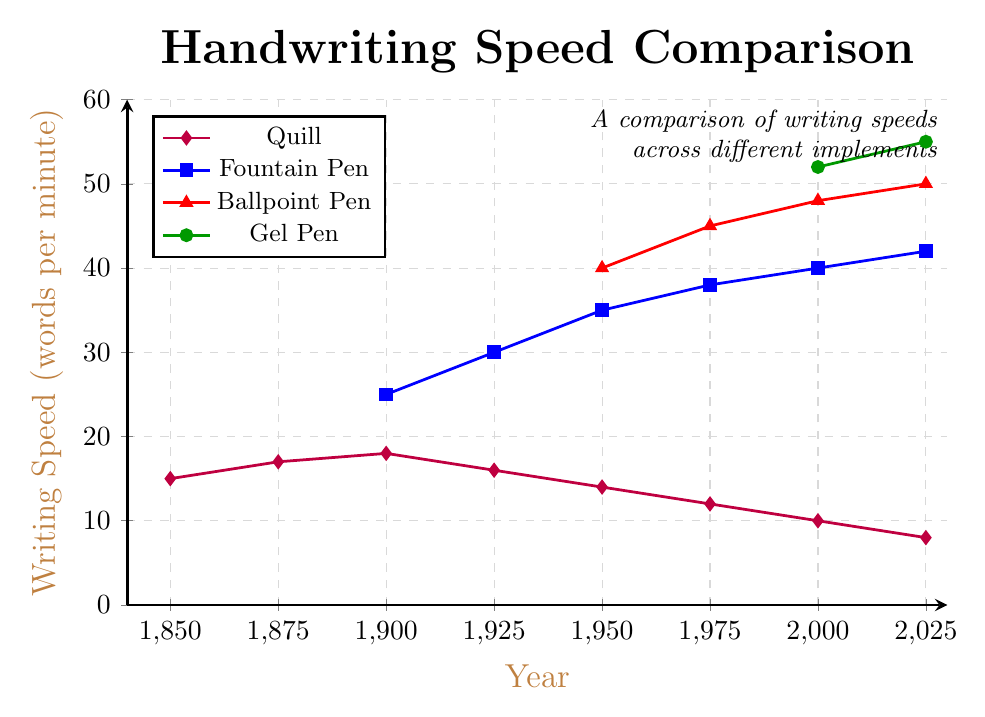When did the writing speed of the Gel Pen first appear on the chart? Gel Pen first appears in the year 2000. This can be seen by locating the first data point of the green line on the horizontal axis.
Answer: 2000 In which year did the Ballpoint Pen have a writing speed equal to 48 words per minute? The red line representing Ballpoint Pen crosses the value of 48 wpm in the year 2000, as seen by matching the red line's y-coordinate with 48 on the left axis.
Answer: 2000 Which writing implement had the highest writing speed in 2025? In 2025, the writing speeds for all implements are shown at the far-right end of the plot. The Gel Pen, indicated by the green line, has the highest value of 55 words per minute.
Answer: Gel Pen What was the difference in writing speed between the Quill and Fountain Pen in 1950? For 1950, the Quill's speed is 14 wpm, and the Fountain Pen's speed is 35 wpm. The difference is 35 - 14 = 21 words per minute.
Answer: 21 words per minute What is the average writing speed of the Quill over all the years shown? The Quill’s writing speeds over the years are: 15, 17, 18, 16, 14, 12, 10, 8. Adding these values gives 110. There are 8 data points, so the average is 110 / 8 = 13.75.
Answer: 13.75 words per minute Between which years did the Fountain Pen see the greatest increase in writing speed? The greatest increase in the Fountain Pen’s speed occurs between its data points. By examining the blue line's slope, the biggest jump is from 1900 (25 words per minute) to 1925 (30 words per minute). The increase is 5 words per minute.
Answer: 1900 to 1925 In 2000, how much faster was the Ballpoint Pen compared to the Quill? In the year 2000, the Ballpoint Pen has a speed of 48 words per minute, and the Quill has a speed of 10 words per minute. The difference is 48 - 10 = 38 words per minute.
Answer: 38 words per minute What trend do you observe for the using a Quill from 1850 to 2025? The Quill’s speed shows a decreasing trend over time. The purple line representing the Quill shows a consistent decline from 15 words per minute in 1850 to 8 words per minute in 2025.
Answer: Decreasing trend Which implement saw an introduction in the chart after the Fountain Pen but before the Gel Pen? The Ballpoint Pen, represented by the red line, appears after the Fountain Pen (blue line starting in 1900) but before the Gel Pen (green line starting in 2000), as it is first shown in 1950.
Answer: Ballpoint Pen What is common about the writing speeds of all implements in the year 2000? In 2000, all implements except Quill show a writing speed range between 40 to 52 words per minute. This can be verified by checking the heights of their lines at the year 2000 mark.
Answer: Range 40-52 words per minute 